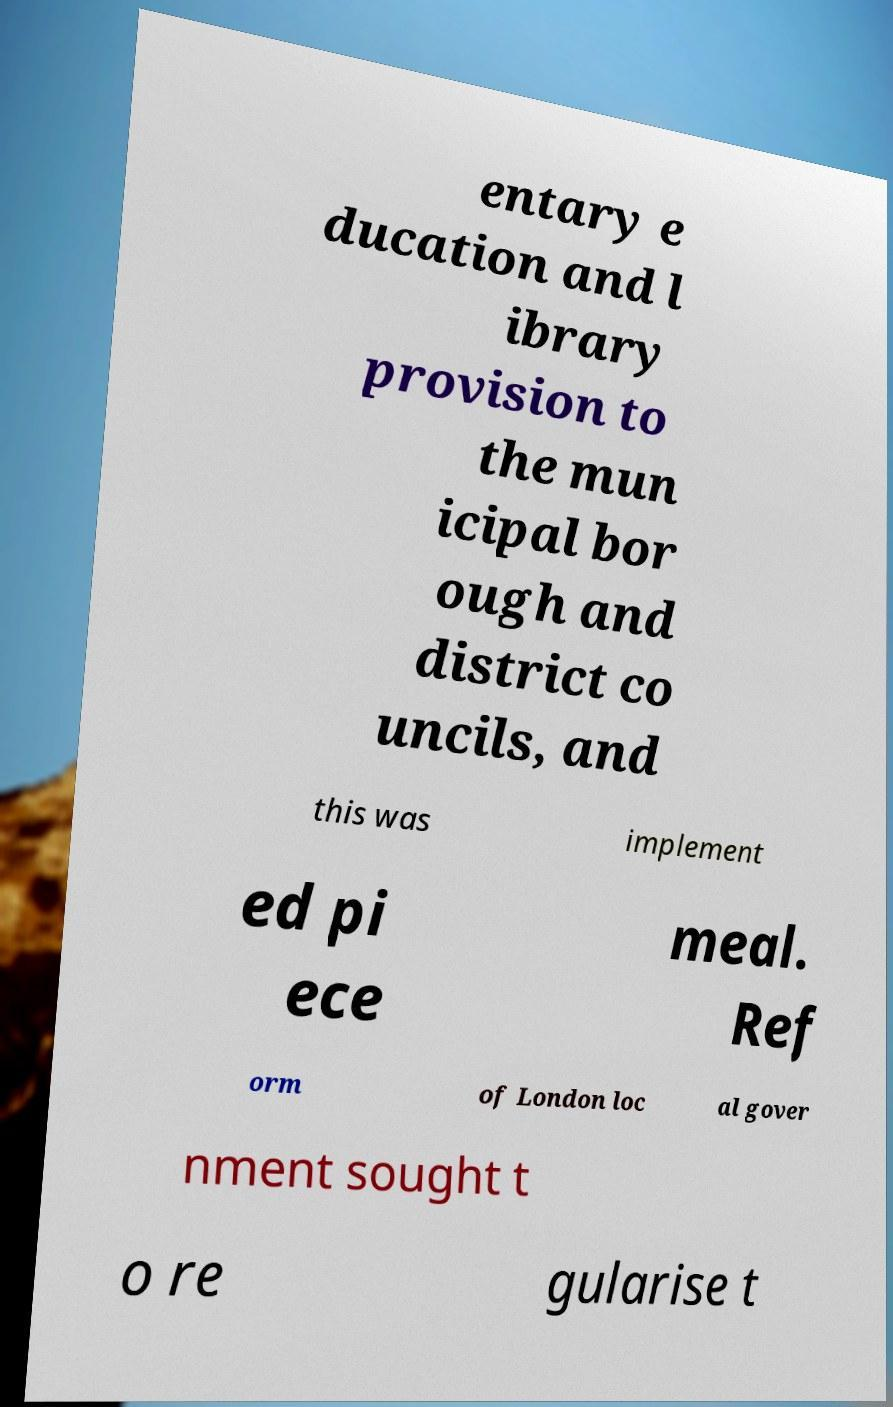Can you accurately transcribe the text from the provided image for me? entary e ducation and l ibrary provision to the mun icipal bor ough and district co uncils, and this was implement ed pi ece meal. Ref orm of London loc al gover nment sought t o re gularise t 